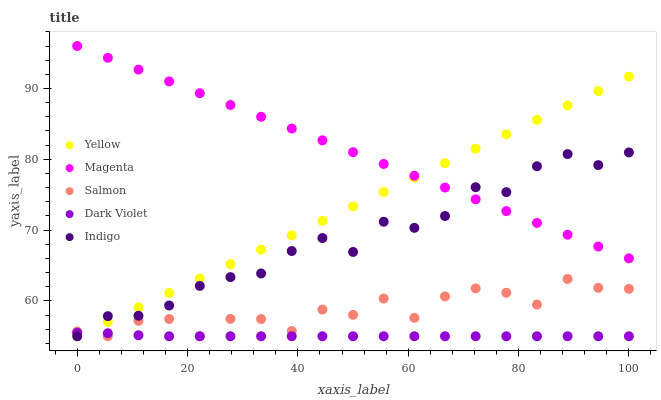Does Dark Violet have the minimum area under the curve?
Answer yes or no. Yes. Does Magenta have the maximum area under the curve?
Answer yes or no. Yes. Does Salmon have the minimum area under the curve?
Answer yes or no. No. Does Salmon have the maximum area under the curve?
Answer yes or no. No. Is Magenta the smoothest?
Answer yes or no. Yes. Is Salmon the roughest?
Answer yes or no. Yes. Is Salmon the smoothest?
Answer yes or no. No. Is Magenta the roughest?
Answer yes or no. No. Does Indigo have the lowest value?
Answer yes or no. Yes. Does Magenta have the lowest value?
Answer yes or no. No. Does Magenta have the highest value?
Answer yes or no. Yes. Does Salmon have the highest value?
Answer yes or no. No. Is Salmon less than Magenta?
Answer yes or no. Yes. Is Magenta greater than Dark Violet?
Answer yes or no. Yes. Does Indigo intersect Salmon?
Answer yes or no. Yes. Is Indigo less than Salmon?
Answer yes or no. No. Is Indigo greater than Salmon?
Answer yes or no. No. Does Salmon intersect Magenta?
Answer yes or no. No. 